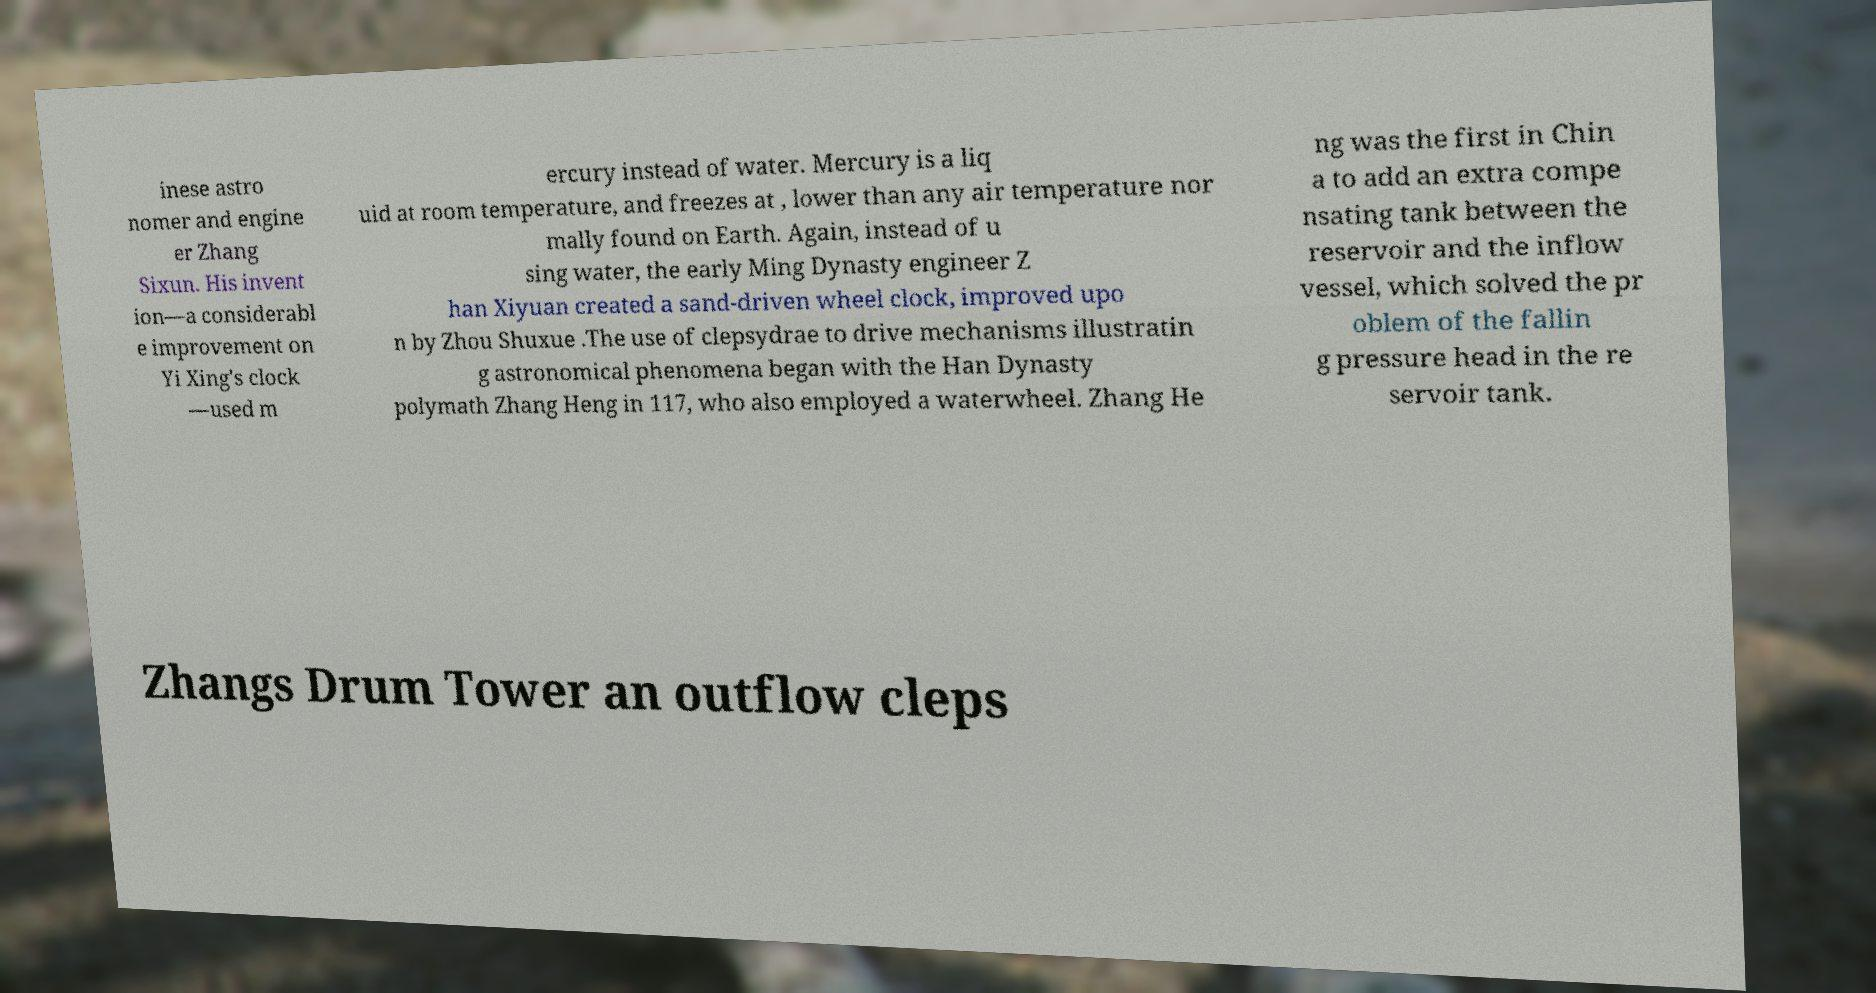Could you assist in decoding the text presented in this image and type it out clearly? inese astro nomer and engine er Zhang Sixun. His invent ion—a considerabl e improvement on Yi Xing's clock —used m ercury instead of water. Mercury is a liq uid at room temperature, and freezes at , lower than any air temperature nor mally found on Earth. Again, instead of u sing water, the early Ming Dynasty engineer Z han Xiyuan created a sand-driven wheel clock, improved upo n by Zhou Shuxue .The use of clepsydrae to drive mechanisms illustratin g astronomical phenomena began with the Han Dynasty polymath Zhang Heng in 117, who also employed a waterwheel. Zhang He ng was the first in Chin a to add an extra compe nsating tank between the reservoir and the inflow vessel, which solved the pr oblem of the fallin g pressure head in the re servoir tank. Zhangs Drum Tower an outflow cleps 